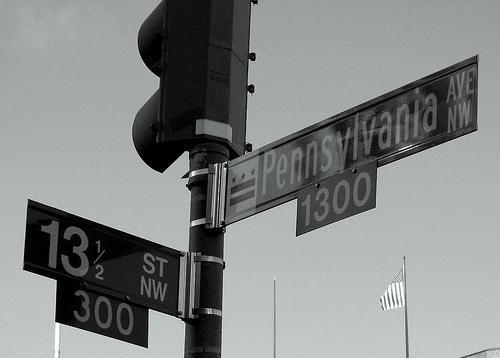How many street signs are there?
Give a very brief answer. 2. 